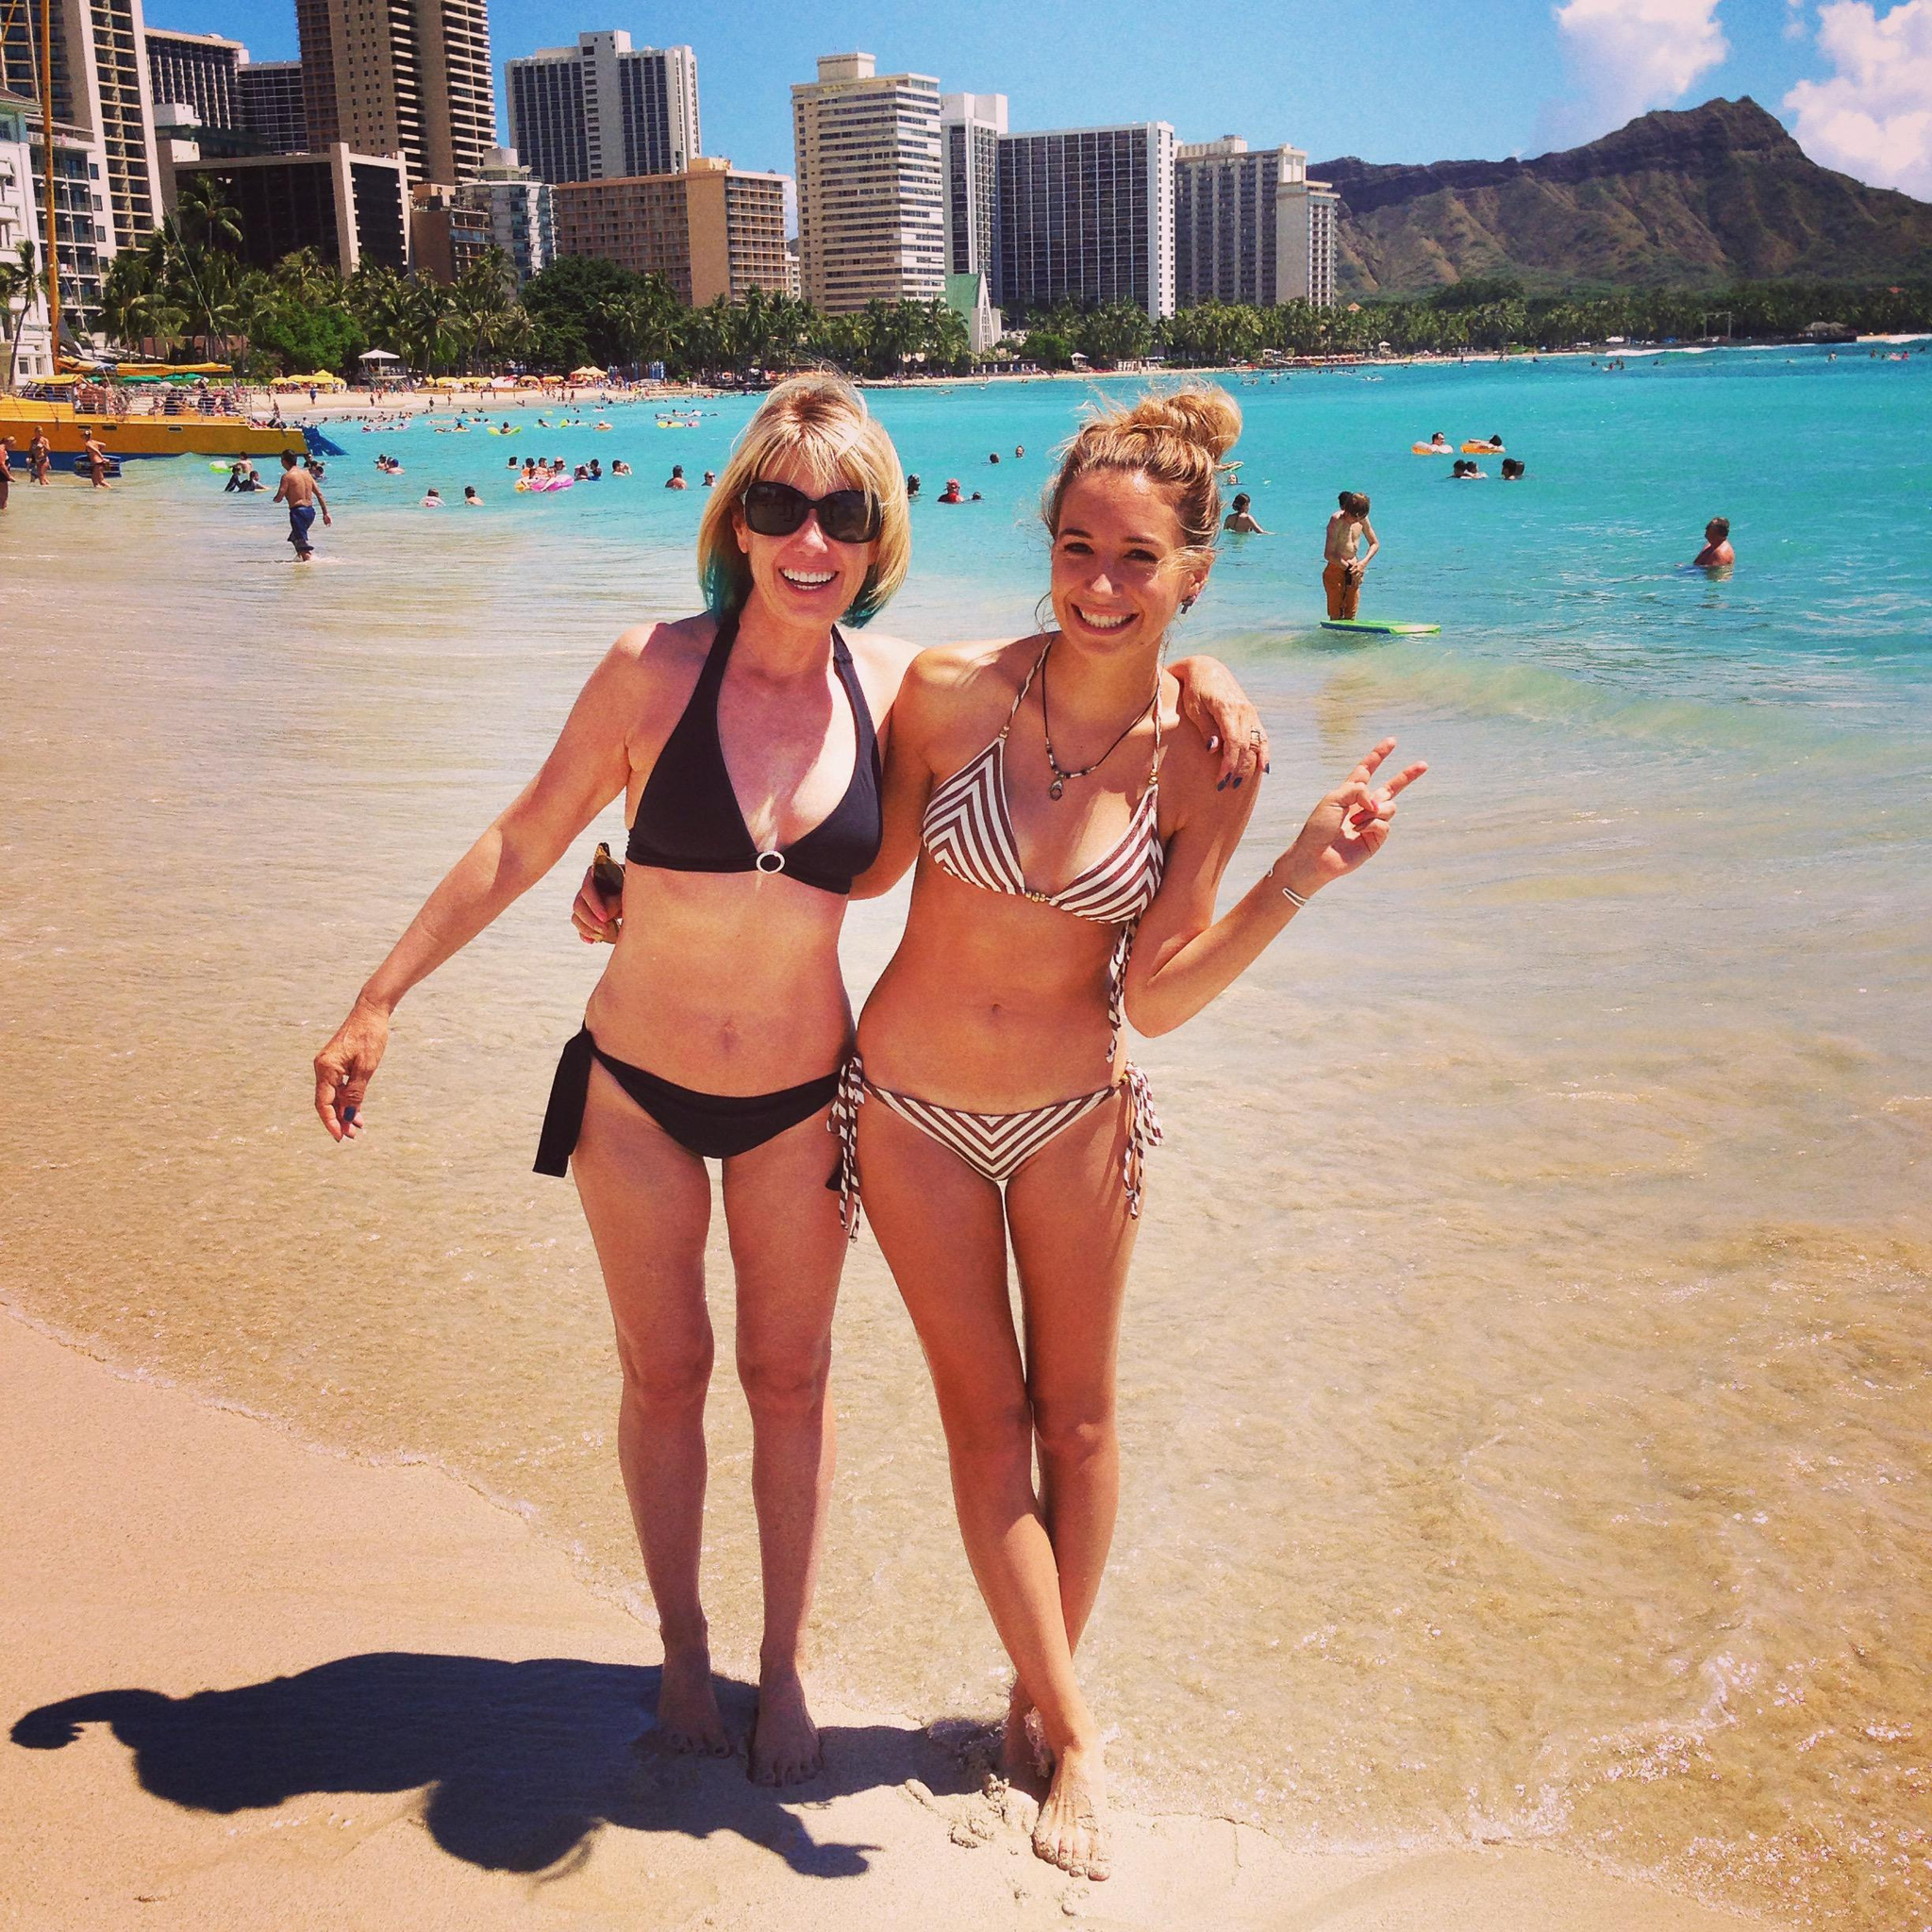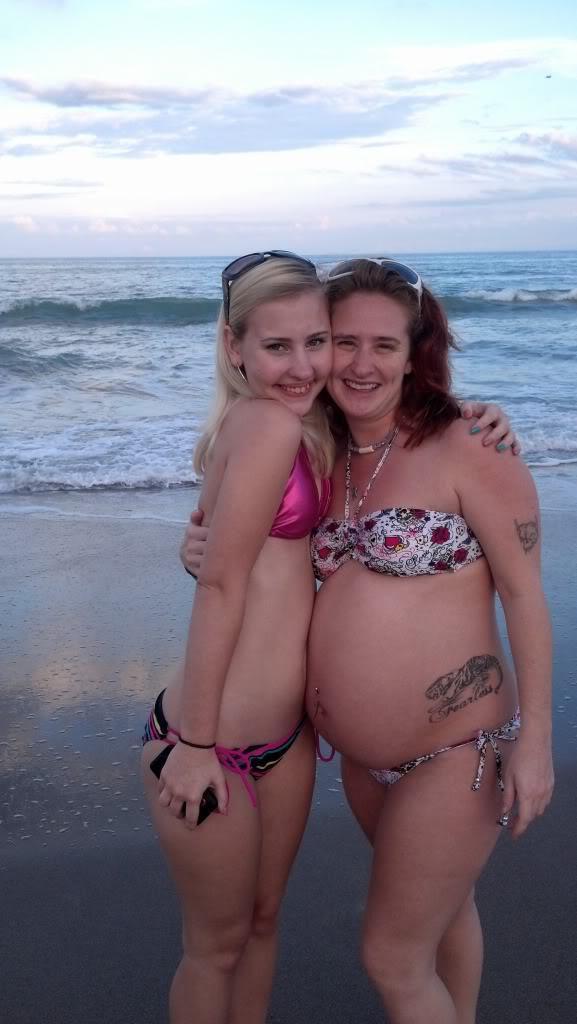The first image is the image on the left, the second image is the image on the right. Examine the images to the left and right. Is the description "One image shows two women side by side modelling bikinis with similar colors." accurate? Answer yes or no. No. The first image is the image on the left, the second image is the image on the right. Evaluate the accuracy of this statement regarding the images: "The combined images show four females in bikinis on the beach, and three bikini tops are the same solid color.". Is it true? Answer yes or no. No. 